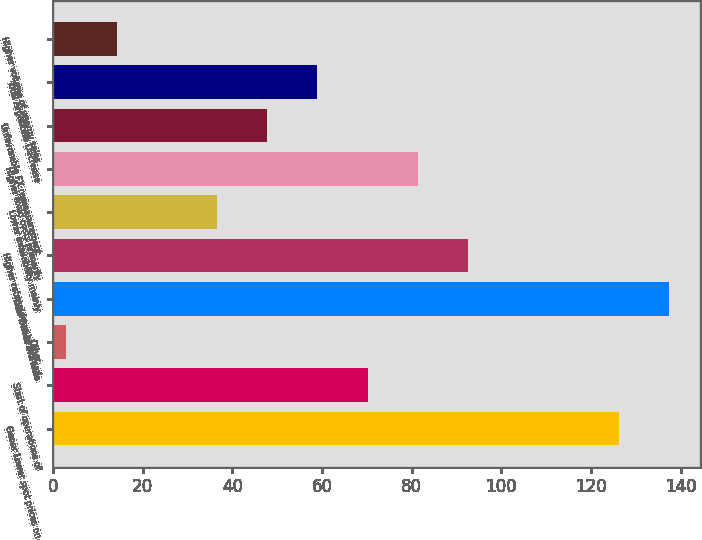<chart> <loc_0><loc_0><loc_500><loc_500><bar_chart><fcel>Gener Lower spot prices on<fcel>Start of operations of<fcel>Other<fcel>Total Gener Increase<fcel>Higher rates driven by annual<fcel>Lower availability mainly<fcel>Higher fixed costs primarily<fcel>Unfavorable FX remeasurement<fcel>Total Argentina Decrease<fcel>Higher volume of energy sales<nl><fcel>126.2<fcel>70.2<fcel>3<fcel>137.4<fcel>92.6<fcel>36.6<fcel>81.4<fcel>47.8<fcel>59<fcel>14.2<nl></chart> 